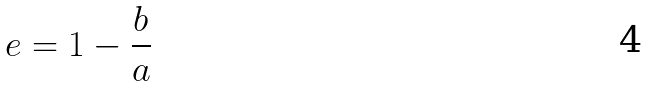<formula> <loc_0><loc_0><loc_500><loc_500>e = 1 - \frac { b } { a }</formula> 